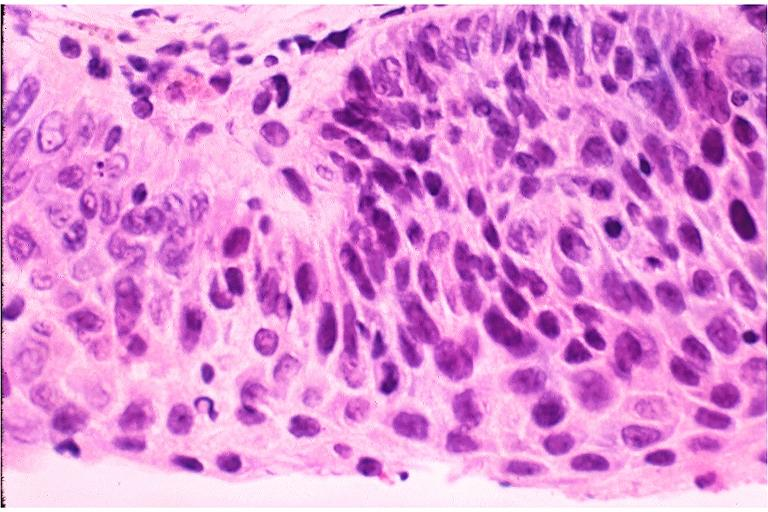does dysplastic show severe epithelial dysplasia?
Answer the question using a single word or phrase. No 